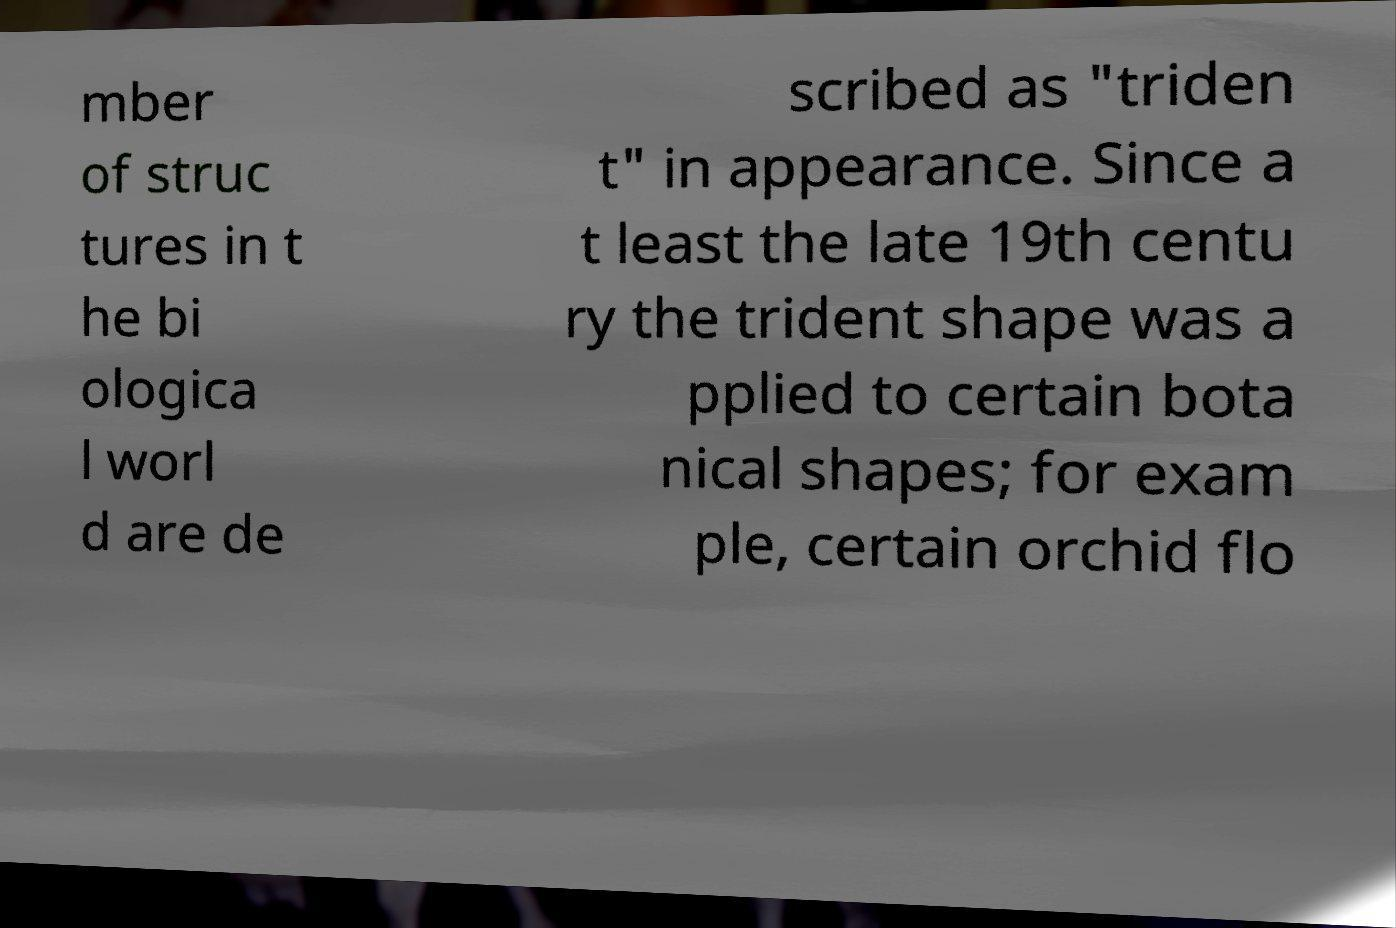Can you accurately transcribe the text from the provided image for me? mber of struc tures in t he bi ologica l worl d are de scribed as "triden t" in appearance. Since a t least the late 19th centu ry the trident shape was a pplied to certain bota nical shapes; for exam ple, certain orchid flo 